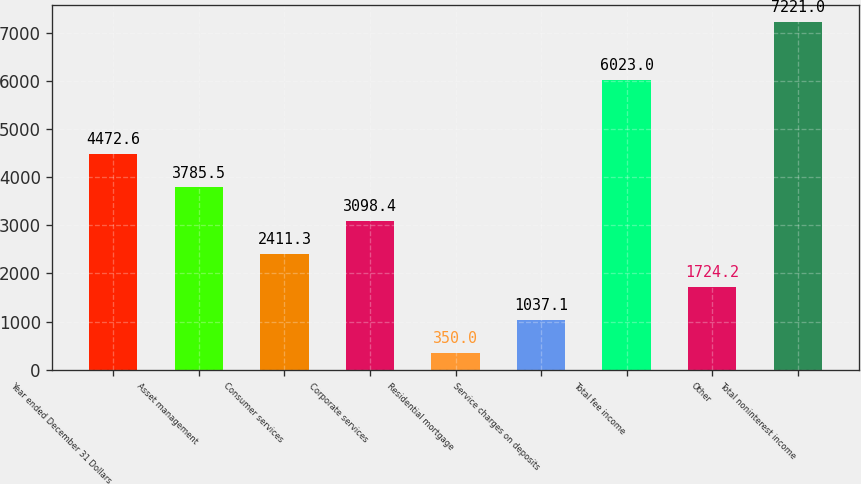Convert chart. <chart><loc_0><loc_0><loc_500><loc_500><bar_chart><fcel>Year ended December 31 Dollars<fcel>Asset management<fcel>Consumer services<fcel>Corporate services<fcel>Residential mortgage<fcel>Service charges on deposits<fcel>Total fee income<fcel>Other<fcel>Total noninterest income<nl><fcel>4472.6<fcel>3785.5<fcel>2411.3<fcel>3098.4<fcel>350<fcel>1037.1<fcel>6023<fcel>1724.2<fcel>7221<nl></chart> 